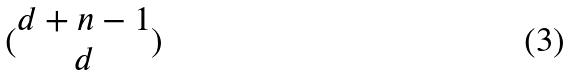<formula> <loc_0><loc_0><loc_500><loc_500>( \begin{matrix} d + n - 1 \\ d \end{matrix} )</formula> 